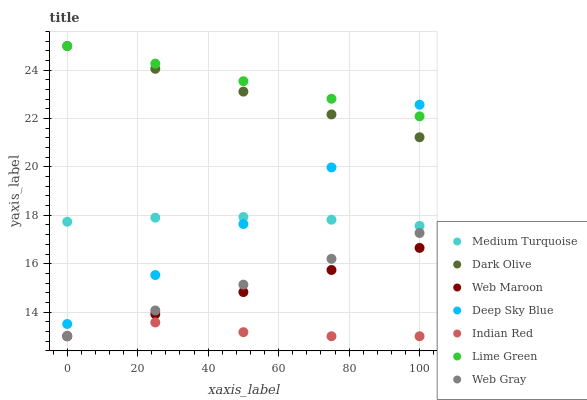Does Indian Red have the minimum area under the curve?
Answer yes or no. Yes. Does Lime Green have the maximum area under the curve?
Answer yes or no. Yes. Does Web Gray have the minimum area under the curve?
Answer yes or no. No. Does Web Gray have the maximum area under the curve?
Answer yes or no. No. Is Web Gray the smoothest?
Answer yes or no. Yes. Is Indian Red the roughest?
Answer yes or no. Yes. Is Deep Sky Blue the smoothest?
Answer yes or no. No. Is Deep Sky Blue the roughest?
Answer yes or no. No. Does Web Gray have the lowest value?
Answer yes or no. Yes. Does Deep Sky Blue have the lowest value?
Answer yes or no. No. Does Lime Green have the highest value?
Answer yes or no. Yes. Does Web Gray have the highest value?
Answer yes or no. No. Is Web Gray less than Deep Sky Blue?
Answer yes or no. Yes. Is Medium Turquoise greater than Web Gray?
Answer yes or no. Yes. Does Deep Sky Blue intersect Medium Turquoise?
Answer yes or no. Yes. Is Deep Sky Blue less than Medium Turquoise?
Answer yes or no. No. Is Deep Sky Blue greater than Medium Turquoise?
Answer yes or no. No. Does Web Gray intersect Deep Sky Blue?
Answer yes or no. No. 